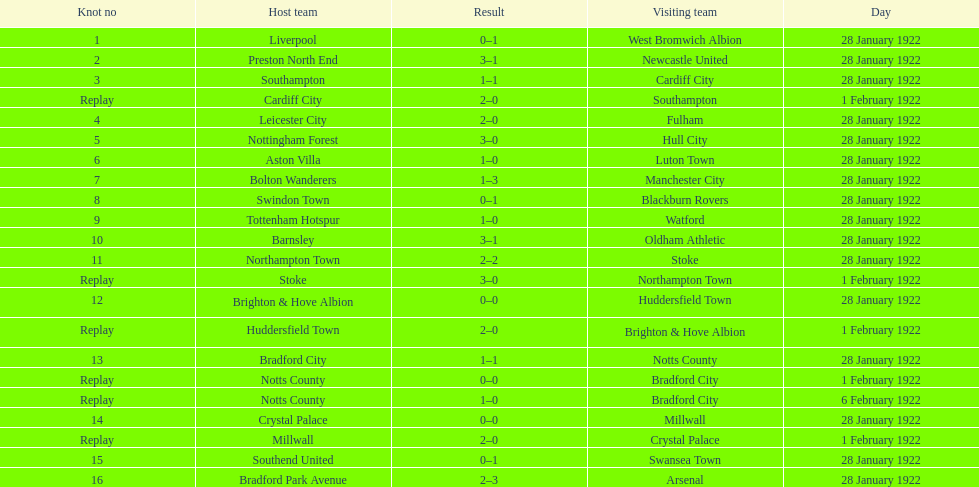What is the number of points scored on 6 february 1922? 1. 